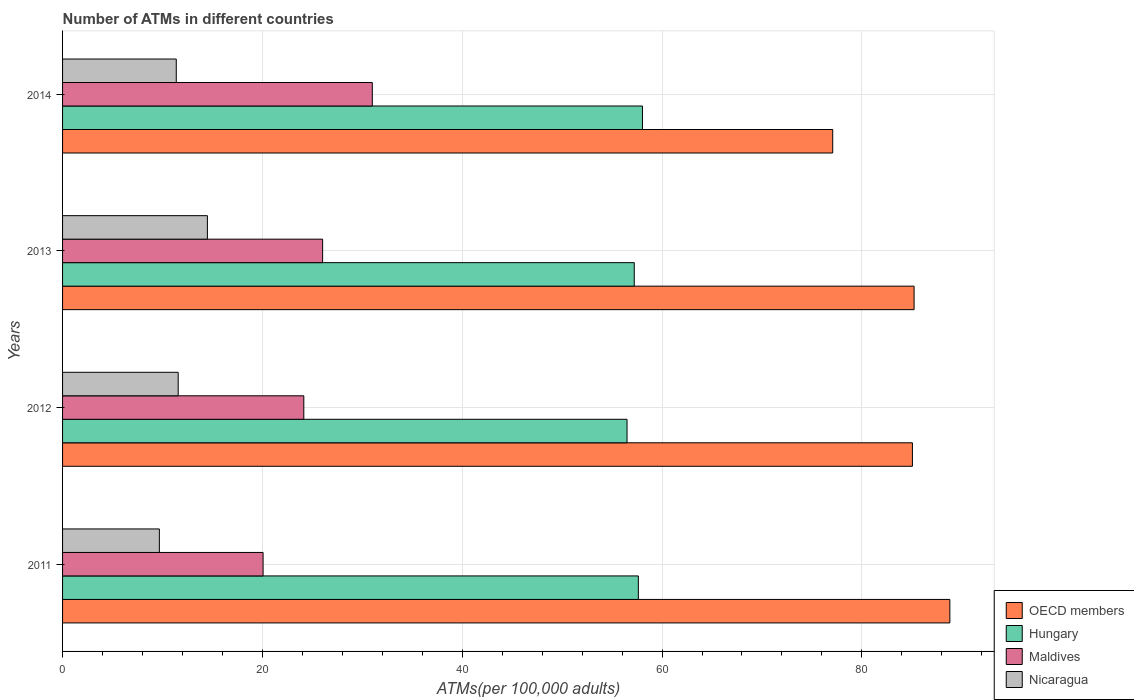How many groups of bars are there?
Offer a very short reply. 4. How many bars are there on the 3rd tick from the bottom?
Ensure brevity in your answer.  4. In how many cases, is the number of bars for a given year not equal to the number of legend labels?
Offer a very short reply. 0. What is the number of ATMs in Hungary in 2013?
Your answer should be very brief. 57.22. Across all years, what is the maximum number of ATMs in Hungary?
Provide a succinct answer. 58.04. Across all years, what is the minimum number of ATMs in Hungary?
Your answer should be compact. 56.49. In which year was the number of ATMs in Maldives minimum?
Offer a terse response. 2011. What is the total number of ATMs in Nicaragua in the graph?
Your answer should be very brief. 47.13. What is the difference between the number of ATMs in OECD members in 2011 and that in 2013?
Ensure brevity in your answer.  3.58. What is the difference between the number of ATMs in Maldives in 2011 and the number of ATMs in OECD members in 2012?
Offer a very short reply. -64.99. What is the average number of ATMs in Nicaragua per year?
Keep it short and to the point. 11.78. In the year 2013, what is the difference between the number of ATMs in Maldives and number of ATMs in Hungary?
Provide a succinct answer. -31.19. What is the ratio of the number of ATMs in OECD members in 2011 to that in 2014?
Offer a terse response. 1.15. What is the difference between the highest and the second highest number of ATMs in OECD members?
Provide a succinct answer. 3.58. What is the difference between the highest and the lowest number of ATMs in Maldives?
Offer a very short reply. 10.93. What does the 1st bar from the top in 2014 represents?
Your response must be concise. Nicaragua. What does the 2nd bar from the bottom in 2013 represents?
Your answer should be very brief. Hungary. Is it the case that in every year, the sum of the number of ATMs in OECD members and number of ATMs in Maldives is greater than the number of ATMs in Hungary?
Keep it short and to the point. Yes. How many years are there in the graph?
Make the answer very short. 4. Are the values on the major ticks of X-axis written in scientific E-notation?
Your answer should be very brief. No. Does the graph contain any zero values?
Your response must be concise. No. Does the graph contain grids?
Keep it short and to the point. Yes. How are the legend labels stacked?
Keep it short and to the point. Vertical. What is the title of the graph?
Make the answer very short. Number of ATMs in different countries. What is the label or title of the X-axis?
Offer a terse response. ATMs(per 100,0 adults). What is the label or title of the Y-axis?
Offer a very short reply. Years. What is the ATMs(per 100,000 adults) in OECD members in 2011?
Provide a succinct answer. 88.81. What is the ATMs(per 100,000 adults) of Hungary in 2011?
Offer a terse response. 57.63. What is the ATMs(per 100,000 adults) in Maldives in 2011?
Provide a short and direct response. 20.07. What is the ATMs(per 100,000 adults) in Nicaragua in 2011?
Your response must be concise. 9.69. What is the ATMs(per 100,000 adults) of OECD members in 2012?
Make the answer very short. 85.06. What is the ATMs(per 100,000 adults) of Hungary in 2012?
Provide a succinct answer. 56.49. What is the ATMs(per 100,000 adults) of Maldives in 2012?
Ensure brevity in your answer.  24.15. What is the ATMs(per 100,000 adults) in Nicaragua in 2012?
Provide a short and direct response. 11.57. What is the ATMs(per 100,000 adults) in OECD members in 2013?
Give a very brief answer. 85.23. What is the ATMs(per 100,000 adults) in Hungary in 2013?
Make the answer very short. 57.22. What is the ATMs(per 100,000 adults) of Maldives in 2013?
Make the answer very short. 26.03. What is the ATMs(per 100,000 adults) in Nicaragua in 2013?
Keep it short and to the point. 14.5. What is the ATMs(per 100,000 adults) in OECD members in 2014?
Keep it short and to the point. 77.08. What is the ATMs(per 100,000 adults) of Hungary in 2014?
Provide a succinct answer. 58.04. What is the ATMs(per 100,000 adults) of Maldives in 2014?
Provide a succinct answer. 31. What is the ATMs(per 100,000 adults) in Nicaragua in 2014?
Your answer should be very brief. 11.38. Across all years, what is the maximum ATMs(per 100,000 adults) of OECD members?
Offer a very short reply. 88.81. Across all years, what is the maximum ATMs(per 100,000 adults) in Hungary?
Provide a short and direct response. 58.04. Across all years, what is the maximum ATMs(per 100,000 adults) in Maldives?
Give a very brief answer. 31. Across all years, what is the maximum ATMs(per 100,000 adults) in Nicaragua?
Make the answer very short. 14.5. Across all years, what is the minimum ATMs(per 100,000 adults) of OECD members?
Your answer should be compact. 77.08. Across all years, what is the minimum ATMs(per 100,000 adults) of Hungary?
Ensure brevity in your answer.  56.49. Across all years, what is the minimum ATMs(per 100,000 adults) of Maldives?
Provide a succinct answer. 20.07. Across all years, what is the minimum ATMs(per 100,000 adults) in Nicaragua?
Give a very brief answer. 9.69. What is the total ATMs(per 100,000 adults) in OECD members in the graph?
Offer a very short reply. 336.17. What is the total ATMs(per 100,000 adults) of Hungary in the graph?
Your answer should be very brief. 229.38. What is the total ATMs(per 100,000 adults) of Maldives in the graph?
Your answer should be very brief. 101.24. What is the total ATMs(per 100,000 adults) of Nicaragua in the graph?
Your response must be concise. 47.13. What is the difference between the ATMs(per 100,000 adults) in OECD members in 2011 and that in 2012?
Your answer should be very brief. 3.75. What is the difference between the ATMs(per 100,000 adults) in Hungary in 2011 and that in 2012?
Your answer should be very brief. 1.13. What is the difference between the ATMs(per 100,000 adults) in Maldives in 2011 and that in 2012?
Offer a terse response. -4.08. What is the difference between the ATMs(per 100,000 adults) of Nicaragua in 2011 and that in 2012?
Offer a terse response. -1.88. What is the difference between the ATMs(per 100,000 adults) of OECD members in 2011 and that in 2013?
Your response must be concise. 3.58. What is the difference between the ATMs(per 100,000 adults) of Hungary in 2011 and that in 2013?
Keep it short and to the point. 0.41. What is the difference between the ATMs(per 100,000 adults) in Maldives in 2011 and that in 2013?
Your response must be concise. -5.96. What is the difference between the ATMs(per 100,000 adults) in Nicaragua in 2011 and that in 2013?
Give a very brief answer. -4.81. What is the difference between the ATMs(per 100,000 adults) of OECD members in 2011 and that in 2014?
Give a very brief answer. 11.72. What is the difference between the ATMs(per 100,000 adults) of Hungary in 2011 and that in 2014?
Offer a very short reply. -0.41. What is the difference between the ATMs(per 100,000 adults) in Maldives in 2011 and that in 2014?
Keep it short and to the point. -10.93. What is the difference between the ATMs(per 100,000 adults) of Nicaragua in 2011 and that in 2014?
Your answer should be compact. -1.69. What is the difference between the ATMs(per 100,000 adults) in OECD members in 2012 and that in 2013?
Make the answer very short. -0.17. What is the difference between the ATMs(per 100,000 adults) in Hungary in 2012 and that in 2013?
Keep it short and to the point. -0.72. What is the difference between the ATMs(per 100,000 adults) in Maldives in 2012 and that in 2013?
Keep it short and to the point. -1.88. What is the difference between the ATMs(per 100,000 adults) of Nicaragua in 2012 and that in 2013?
Make the answer very short. -2.92. What is the difference between the ATMs(per 100,000 adults) of OECD members in 2012 and that in 2014?
Your answer should be very brief. 7.98. What is the difference between the ATMs(per 100,000 adults) in Hungary in 2012 and that in 2014?
Offer a terse response. -1.54. What is the difference between the ATMs(per 100,000 adults) in Maldives in 2012 and that in 2014?
Make the answer very short. -6.85. What is the difference between the ATMs(per 100,000 adults) of Nicaragua in 2012 and that in 2014?
Offer a terse response. 0.19. What is the difference between the ATMs(per 100,000 adults) in OECD members in 2013 and that in 2014?
Your answer should be compact. 8.14. What is the difference between the ATMs(per 100,000 adults) of Hungary in 2013 and that in 2014?
Offer a terse response. -0.82. What is the difference between the ATMs(per 100,000 adults) in Maldives in 2013 and that in 2014?
Make the answer very short. -4.97. What is the difference between the ATMs(per 100,000 adults) in Nicaragua in 2013 and that in 2014?
Your answer should be very brief. 3.12. What is the difference between the ATMs(per 100,000 adults) of OECD members in 2011 and the ATMs(per 100,000 adults) of Hungary in 2012?
Provide a succinct answer. 32.31. What is the difference between the ATMs(per 100,000 adults) of OECD members in 2011 and the ATMs(per 100,000 adults) of Maldives in 2012?
Your answer should be compact. 64.66. What is the difference between the ATMs(per 100,000 adults) of OECD members in 2011 and the ATMs(per 100,000 adults) of Nicaragua in 2012?
Offer a very short reply. 77.23. What is the difference between the ATMs(per 100,000 adults) in Hungary in 2011 and the ATMs(per 100,000 adults) in Maldives in 2012?
Offer a terse response. 33.48. What is the difference between the ATMs(per 100,000 adults) of Hungary in 2011 and the ATMs(per 100,000 adults) of Nicaragua in 2012?
Give a very brief answer. 46.06. What is the difference between the ATMs(per 100,000 adults) in Maldives in 2011 and the ATMs(per 100,000 adults) in Nicaragua in 2012?
Ensure brevity in your answer.  8.5. What is the difference between the ATMs(per 100,000 adults) of OECD members in 2011 and the ATMs(per 100,000 adults) of Hungary in 2013?
Provide a succinct answer. 31.59. What is the difference between the ATMs(per 100,000 adults) of OECD members in 2011 and the ATMs(per 100,000 adults) of Maldives in 2013?
Offer a very short reply. 62.78. What is the difference between the ATMs(per 100,000 adults) of OECD members in 2011 and the ATMs(per 100,000 adults) of Nicaragua in 2013?
Provide a succinct answer. 74.31. What is the difference between the ATMs(per 100,000 adults) in Hungary in 2011 and the ATMs(per 100,000 adults) in Maldives in 2013?
Keep it short and to the point. 31.6. What is the difference between the ATMs(per 100,000 adults) of Hungary in 2011 and the ATMs(per 100,000 adults) of Nicaragua in 2013?
Provide a short and direct response. 43.13. What is the difference between the ATMs(per 100,000 adults) of Maldives in 2011 and the ATMs(per 100,000 adults) of Nicaragua in 2013?
Give a very brief answer. 5.57. What is the difference between the ATMs(per 100,000 adults) in OECD members in 2011 and the ATMs(per 100,000 adults) in Hungary in 2014?
Ensure brevity in your answer.  30.77. What is the difference between the ATMs(per 100,000 adults) of OECD members in 2011 and the ATMs(per 100,000 adults) of Maldives in 2014?
Ensure brevity in your answer.  57.8. What is the difference between the ATMs(per 100,000 adults) in OECD members in 2011 and the ATMs(per 100,000 adults) in Nicaragua in 2014?
Your response must be concise. 77.43. What is the difference between the ATMs(per 100,000 adults) of Hungary in 2011 and the ATMs(per 100,000 adults) of Maldives in 2014?
Provide a short and direct response. 26.63. What is the difference between the ATMs(per 100,000 adults) of Hungary in 2011 and the ATMs(per 100,000 adults) of Nicaragua in 2014?
Provide a short and direct response. 46.25. What is the difference between the ATMs(per 100,000 adults) in Maldives in 2011 and the ATMs(per 100,000 adults) in Nicaragua in 2014?
Provide a succinct answer. 8.69. What is the difference between the ATMs(per 100,000 adults) in OECD members in 2012 and the ATMs(per 100,000 adults) in Hungary in 2013?
Your response must be concise. 27.84. What is the difference between the ATMs(per 100,000 adults) of OECD members in 2012 and the ATMs(per 100,000 adults) of Maldives in 2013?
Give a very brief answer. 59.03. What is the difference between the ATMs(per 100,000 adults) of OECD members in 2012 and the ATMs(per 100,000 adults) of Nicaragua in 2013?
Offer a terse response. 70.56. What is the difference between the ATMs(per 100,000 adults) in Hungary in 2012 and the ATMs(per 100,000 adults) in Maldives in 2013?
Offer a very short reply. 30.47. What is the difference between the ATMs(per 100,000 adults) in Hungary in 2012 and the ATMs(per 100,000 adults) in Nicaragua in 2013?
Your answer should be compact. 42. What is the difference between the ATMs(per 100,000 adults) in Maldives in 2012 and the ATMs(per 100,000 adults) in Nicaragua in 2013?
Offer a terse response. 9.65. What is the difference between the ATMs(per 100,000 adults) of OECD members in 2012 and the ATMs(per 100,000 adults) of Hungary in 2014?
Offer a terse response. 27.02. What is the difference between the ATMs(per 100,000 adults) of OECD members in 2012 and the ATMs(per 100,000 adults) of Maldives in 2014?
Give a very brief answer. 54.06. What is the difference between the ATMs(per 100,000 adults) in OECD members in 2012 and the ATMs(per 100,000 adults) in Nicaragua in 2014?
Ensure brevity in your answer.  73.68. What is the difference between the ATMs(per 100,000 adults) of Hungary in 2012 and the ATMs(per 100,000 adults) of Maldives in 2014?
Your answer should be very brief. 25.49. What is the difference between the ATMs(per 100,000 adults) of Hungary in 2012 and the ATMs(per 100,000 adults) of Nicaragua in 2014?
Give a very brief answer. 45.12. What is the difference between the ATMs(per 100,000 adults) in Maldives in 2012 and the ATMs(per 100,000 adults) in Nicaragua in 2014?
Keep it short and to the point. 12.77. What is the difference between the ATMs(per 100,000 adults) of OECD members in 2013 and the ATMs(per 100,000 adults) of Hungary in 2014?
Your answer should be compact. 27.19. What is the difference between the ATMs(per 100,000 adults) in OECD members in 2013 and the ATMs(per 100,000 adults) in Maldives in 2014?
Offer a terse response. 54.22. What is the difference between the ATMs(per 100,000 adults) of OECD members in 2013 and the ATMs(per 100,000 adults) of Nicaragua in 2014?
Your answer should be very brief. 73.85. What is the difference between the ATMs(per 100,000 adults) of Hungary in 2013 and the ATMs(per 100,000 adults) of Maldives in 2014?
Your answer should be very brief. 26.22. What is the difference between the ATMs(per 100,000 adults) of Hungary in 2013 and the ATMs(per 100,000 adults) of Nicaragua in 2014?
Your answer should be compact. 45.84. What is the difference between the ATMs(per 100,000 adults) in Maldives in 2013 and the ATMs(per 100,000 adults) in Nicaragua in 2014?
Keep it short and to the point. 14.65. What is the average ATMs(per 100,000 adults) of OECD members per year?
Your answer should be very brief. 84.04. What is the average ATMs(per 100,000 adults) of Hungary per year?
Offer a very short reply. 57.34. What is the average ATMs(per 100,000 adults) in Maldives per year?
Offer a very short reply. 25.31. What is the average ATMs(per 100,000 adults) of Nicaragua per year?
Offer a very short reply. 11.78. In the year 2011, what is the difference between the ATMs(per 100,000 adults) of OECD members and ATMs(per 100,000 adults) of Hungary?
Ensure brevity in your answer.  31.18. In the year 2011, what is the difference between the ATMs(per 100,000 adults) of OECD members and ATMs(per 100,000 adults) of Maldives?
Ensure brevity in your answer.  68.74. In the year 2011, what is the difference between the ATMs(per 100,000 adults) of OECD members and ATMs(per 100,000 adults) of Nicaragua?
Ensure brevity in your answer.  79.12. In the year 2011, what is the difference between the ATMs(per 100,000 adults) of Hungary and ATMs(per 100,000 adults) of Maldives?
Provide a succinct answer. 37.56. In the year 2011, what is the difference between the ATMs(per 100,000 adults) in Hungary and ATMs(per 100,000 adults) in Nicaragua?
Ensure brevity in your answer.  47.94. In the year 2011, what is the difference between the ATMs(per 100,000 adults) of Maldives and ATMs(per 100,000 adults) of Nicaragua?
Your answer should be compact. 10.38. In the year 2012, what is the difference between the ATMs(per 100,000 adults) of OECD members and ATMs(per 100,000 adults) of Hungary?
Make the answer very short. 28.56. In the year 2012, what is the difference between the ATMs(per 100,000 adults) in OECD members and ATMs(per 100,000 adults) in Maldives?
Provide a short and direct response. 60.91. In the year 2012, what is the difference between the ATMs(per 100,000 adults) of OECD members and ATMs(per 100,000 adults) of Nicaragua?
Keep it short and to the point. 73.49. In the year 2012, what is the difference between the ATMs(per 100,000 adults) of Hungary and ATMs(per 100,000 adults) of Maldives?
Provide a short and direct response. 32.35. In the year 2012, what is the difference between the ATMs(per 100,000 adults) of Hungary and ATMs(per 100,000 adults) of Nicaragua?
Keep it short and to the point. 44.92. In the year 2012, what is the difference between the ATMs(per 100,000 adults) of Maldives and ATMs(per 100,000 adults) of Nicaragua?
Your response must be concise. 12.57. In the year 2013, what is the difference between the ATMs(per 100,000 adults) of OECD members and ATMs(per 100,000 adults) of Hungary?
Ensure brevity in your answer.  28.01. In the year 2013, what is the difference between the ATMs(per 100,000 adults) in OECD members and ATMs(per 100,000 adults) in Maldives?
Give a very brief answer. 59.2. In the year 2013, what is the difference between the ATMs(per 100,000 adults) of OECD members and ATMs(per 100,000 adults) of Nicaragua?
Your answer should be compact. 70.73. In the year 2013, what is the difference between the ATMs(per 100,000 adults) in Hungary and ATMs(per 100,000 adults) in Maldives?
Give a very brief answer. 31.19. In the year 2013, what is the difference between the ATMs(per 100,000 adults) in Hungary and ATMs(per 100,000 adults) in Nicaragua?
Keep it short and to the point. 42.72. In the year 2013, what is the difference between the ATMs(per 100,000 adults) in Maldives and ATMs(per 100,000 adults) in Nicaragua?
Your response must be concise. 11.53. In the year 2014, what is the difference between the ATMs(per 100,000 adults) of OECD members and ATMs(per 100,000 adults) of Hungary?
Offer a terse response. 19.04. In the year 2014, what is the difference between the ATMs(per 100,000 adults) in OECD members and ATMs(per 100,000 adults) in Maldives?
Provide a short and direct response. 46.08. In the year 2014, what is the difference between the ATMs(per 100,000 adults) in OECD members and ATMs(per 100,000 adults) in Nicaragua?
Your response must be concise. 65.7. In the year 2014, what is the difference between the ATMs(per 100,000 adults) in Hungary and ATMs(per 100,000 adults) in Maldives?
Give a very brief answer. 27.04. In the year 2014, what is the difference between the ATMs(per 100,000 adults) in Hungary and ATMs(per 100,000 adults) in Nicaragua?
Ensure brevity in your answer.  46.66. In the year 2014, what is the difference between the ATMs(per 100,000 adults) in Maldives and ATMs(per 100,000 adults) in Nicaragua?
Your answer should be compact. 19.62. What is the ratio of the ATMs(per 100,000 adults) of OECD members in 2011 to that in 2012?
Your answer should be very brief. 1.04. What is the ratio of the ATMs(per 100,000 adults) of Hungary in 2011 to that in 2012?
Make the answer very short. 1.02. What is the ratio of the ATMs(per 100,000 adults) in Maldives in 2011 to that in 2012?
Ensure brevity in your answer.  0.83. What is the ratio of the ATMs(per 100,000 adults) of Nicaragua in 2011 to that in 2012?
Ensure brevity in your answer.  0.84. What is the ratio of the ATMs(per 100,000 adults) in OECD members in 2011 to that in 2013?
Offer a very short reply. 1.04. What is the ratio of the ATMs(per 100,000 adults) of Maldives in 2011 to that in 2013?
Give a very brief answer. 0.77. What is the ratio of the ATMs(per 100,000 adults) in Nicaragua in 2011 to that in 2013?
Your answer should be very brief. 0.67. What is the ratio of the ATMs(per 100,000 adults) of OECD members in 2011 to that in 2014?
Make the answer very short. 1.15. What is the ratio of the ATMs(per 100,000 adults) of Hungary in 2011 to that in 2014?
Provide a succinct answer. 0.99. What is the ratio of the ATMs(per 100,000 adults) in Maldives in 2011 to that in 2014?
Keep it short and to the point. 0.65. What is the ratio of the ATMs(per 100,000 adults) in Nicaragua in 2011 to that in 2014?
Give a very brief answer. 0.85. What is the ratio of the ATMs(per 100,000 adults) of OECD members in 2012 to that in 2013?
Provide a short and direct response. 1. What is the ratio of the ATMs(per 100,000 adults) of Hungary in 2012 to that in 2013?
Your answer should be compact. 0.99. What is the ratio of the ATMs(per 100,000 adults) of Maldives in 2012 to that in 2013?
Offer a very short reply. 0.93. What is the ratio of the ATMs(per 100,000 adults) in Nicaragua in 2012 to that in 2013?
Provide a short and direct response. 0.8. What is the ratio of the ATMs(per 100,000 adults) in OECD members in 2012 to that in 2014?
Your answer should be very brief. 1.1. What is the ratio of the ATMs(per 100,000 adults) in Hungary in 2012 to that in 2014?
Your response must be concise. 0.97. What is the ratio of the ATMs(per 100,000 adults) of Maldives in 2012 to that in 2014?
Offer a very short reply. 0.78. What is the ratio of the ATMs(per 100,000 adults) of Nicaragua in 2012 to that in 2014?
Offer a very short reply. 1.02. What is the ratio of the ATMs(per 100,000 adults) in OECD members in 2013 to that in 2014?
Give a very brief answer. 1.11. What is the ratio of the ATMs(per 100,000 adults) in Hungary in 2013 to that in 2014?
Make the answer very short. 0.99. What is the ratio of the ATMs(per 100,000 adults) of Maldives in 2013 to that in 2014?
Provide a succinct answer. 0.84. What is the ratio of the ATMs(per 100,000 adults) of Nicaragua in 2013 to that in 2014?
Your response must be concise. 1.27. What is the difference between the highest and the second highest ATMs(per 100,000 adults) of OECD members?
Offer a terse response. 3.58. What is the difference between the highest and the second highest ATMs(per 100,000 adults) of Hungary?
Keep it short and to the point. 0.41. What is the difference between the highest and the second highest ATMs(per 100,000 adults) of Maldives?
Offer a very short reply. 4.97. What is the difference between the highest and the second highest ATMs(per 100,000 adults) of Nicaragua?
Offer a very short reply. 2.92. What is the difference between the highest and the lowest ATMs(per 100,000 adults) in OECD members?
Keep it short and to the point. 11.72. What is the difference between the highest and the lowest ATMs(per 100,000 adults) of Hungary?
Your answer should be very brief. 1.54. What is the difference between the highest and the lowest ATMs(per 100,000 adults) of Maldives?
Keep it short and to the point. 10.93. What is the difference between the highest and the lowest ATMs(per 100,000 adults) in Nicaragua?
Ensure brevity in your answer.  4.81. 